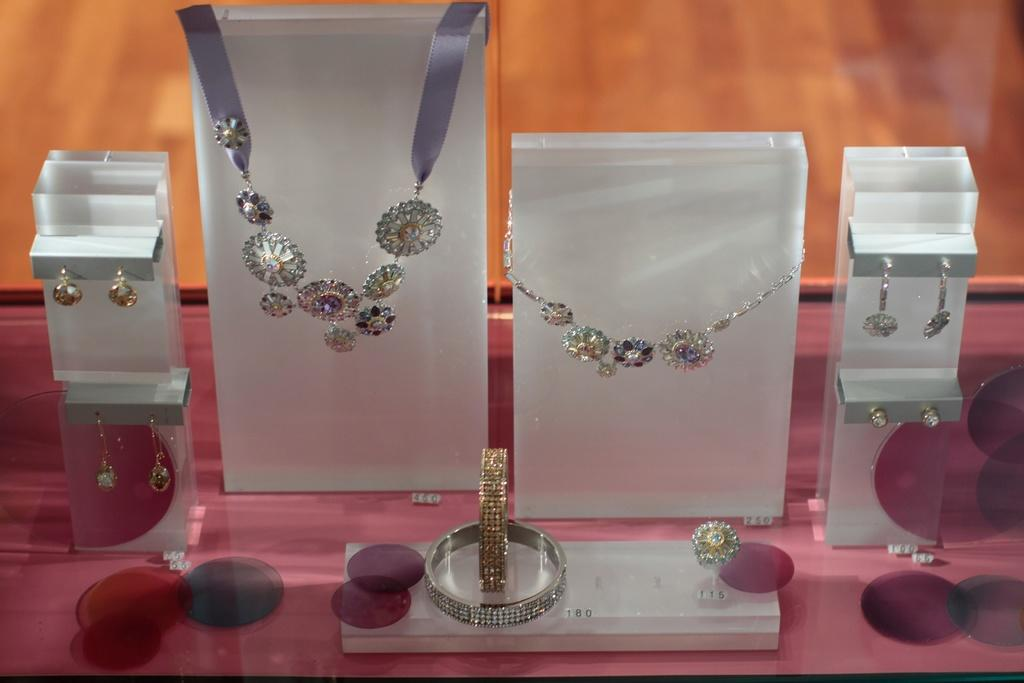What type of items can be seen in the image? There are jewelry items in the image. What color is the background of the image? The background of the image is orange. What type of key is used to unlock the belief in the image? There is no key or belief present in the image; it only features jewelry items and an orange background. 